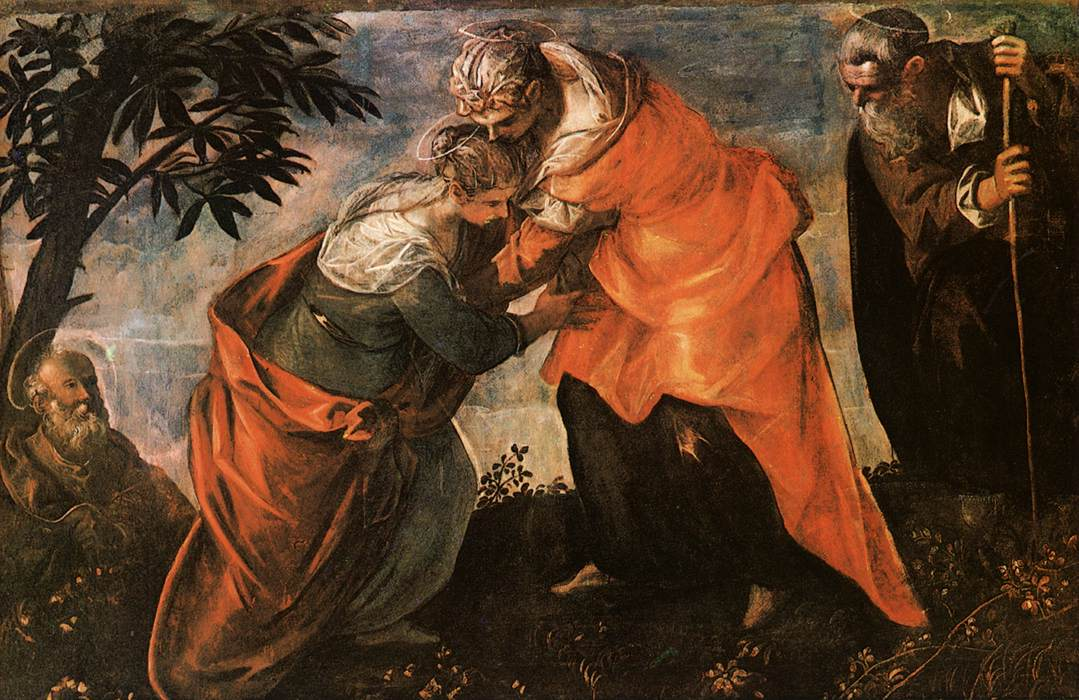Describe a realistic short scenario based on this painting. In a quiet, secluded garden, Mary hastens to embrace her elder cousin Elizabeth, their sacred joy resonating in the serene surroundings. Elizabeth, feeling the movement of the child within her, blesses Mary, pronouncing her fortune and divine favor. Joseph, standing nearby, watches over them with protective adoration. The sunlight filtering through the trees bathes the scene in a warm glow, enhancing the intimate and momentous nature of their encounter. 